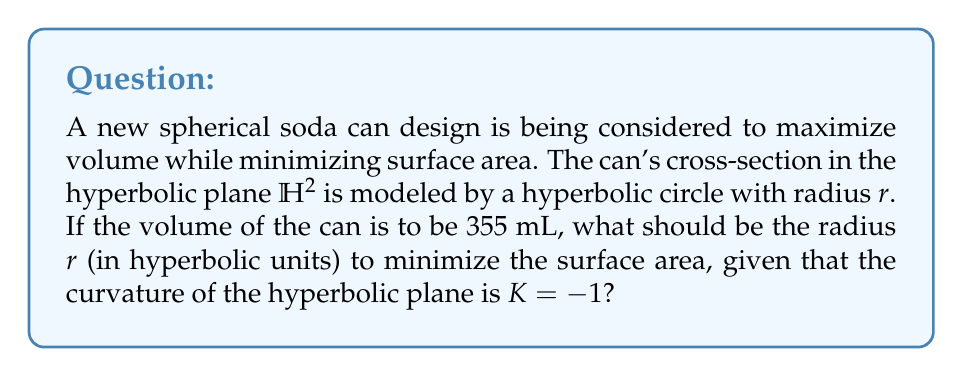Solve this math problem. Let's approach this step-by-step:

1) In hyperbolic geometry with curvature $K = -1$, the area $A$ of a circle with radius $r$ is given by:

   $$A = 4\pi \sinh^2(\frac{r}{2})$$

2) The circumference $C$ of this circle is:

   $$C = 2\pi \sinh(r)$$

3) To find the volume $V$ of the can, we need to multiply the area by the height $h$:

   $$V = h \cdot 4\pi \sinh^2(\frac{r}{2})$$

4) The surface area $S$ of the can consists of the lateral surface area and two circular ends:

   $$S = 2\pi h \sinh(r) + 8\pi \sinh^2(\frac{r}{2})$$

5) We want to minimize $S$ subject to the constraint that $V = 355$ mL. Let's express $h$ in terms of $r$ using the volume constraint:

   $$h = \frac{355}{4\pi \sinh^2(\frac{r}{2})}$$

6) Substituting this into the surface area equation:

   $$S = 2\pi \cdot \frac{355}{4\pi \sinh^2(\frac{r}{2})} \cdot \sinh(r) + 8\pi \sinh^2(\frac{r}{2})$$

7) To minimize $S$, we differentiate with respect to $r$ and set it to zero:

   $$\frac{dS}{dr} = \frac{355 \cosh(r)}{2\sinh^2(\frac{r}{2})} - \frac{355 \sinh(r)}{\sinh^3(\frac{r}{2})} \cdot \frac{1}{2}\cosh(\frac{r}{2}) + 8\pi \sinh(\frac{r}{2})\cosh(\frac{r}{2}) = 0$$

8) This equation can be simplified using hyperbolic trigonometric identities:

   $$\frac{355}{2\sinh(\frac{r}{2})} - \frac{355}{\sinh^3(\frac{r}{2})} \cdot \frac{1}{2}\cosh(\frac{r}{2}) + 4\pi \sinh(r) = 0$$

9) Solving this equation numerically (as it's transcendental) gives us the optimal radius $r$.
Answer: $r \approx 1.317$ hyperbolic units 